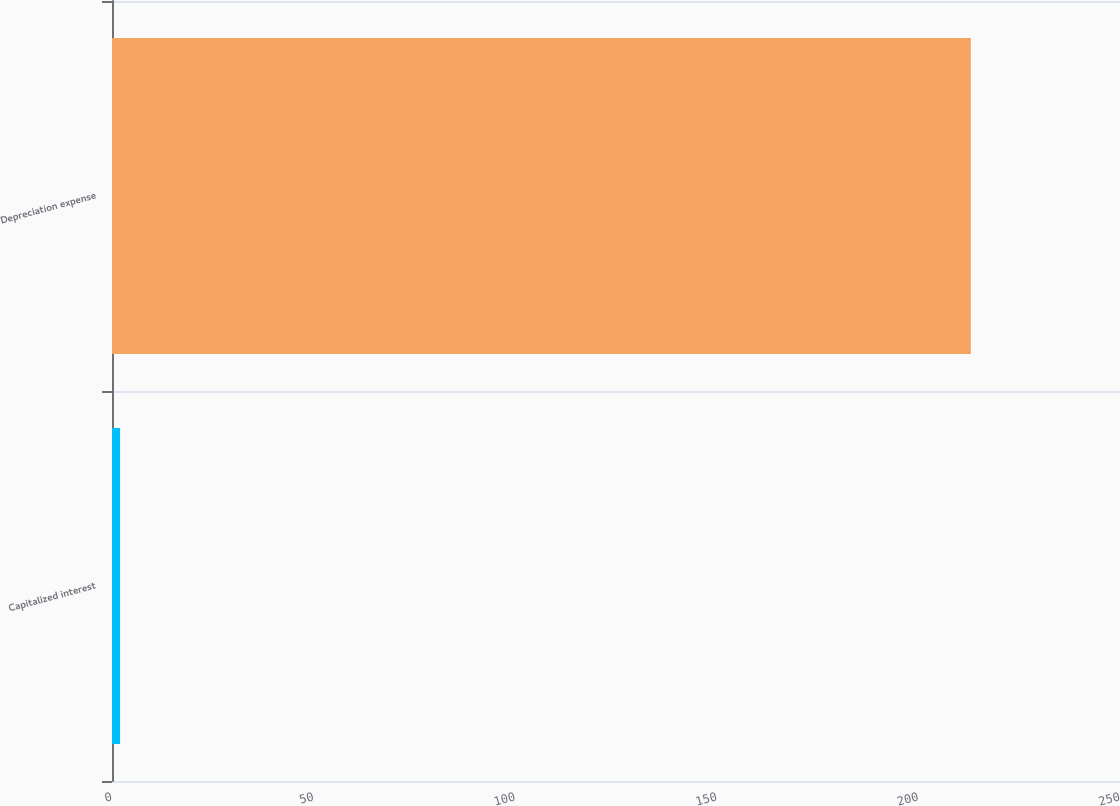Convert chart. <chart><loc_0><loc_0><loc_500><loc_500><bar_chart><fcel>Capitalized interest<fcel>Depreciation expense<nl><fcel>2<fcel>213<nl></chart> 